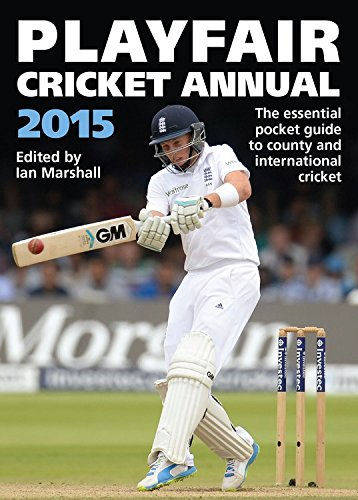Is this a games related book? Yes, this book is related to the game of cricket, providing a detailed annual overview of the sport's developments and player statistics. 